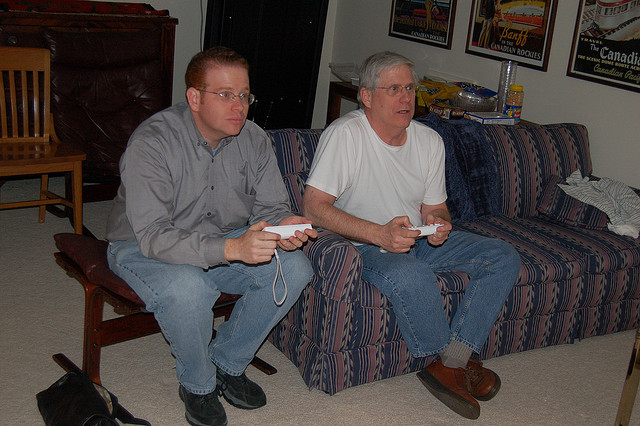Identify the text contained in this image. canadi 